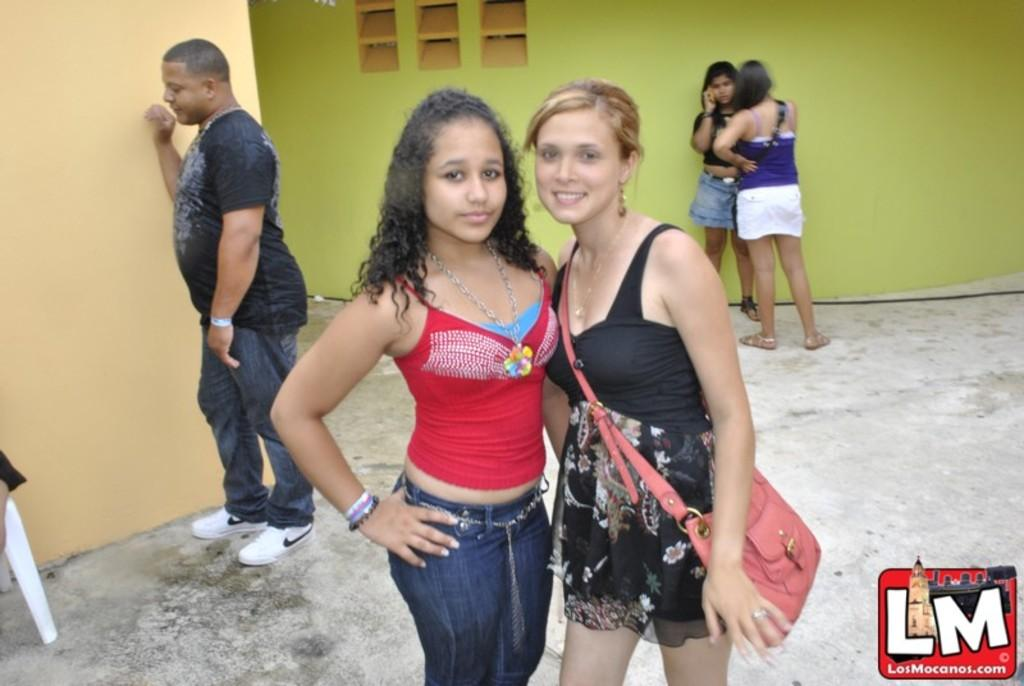How many women are present in the image? There are two women standing in the image. What is the position of the person in the image? There is a person sitting on a chair in the image. Can you describe the position of the other people in the image? There are people standing beside the walls in the image. What type of twig is being used by the women in the image? There is no twig present in the image. What adjustment is being made by the person sitting on the chair in the image? There is no adjustment being made by the person sitting on the chair in the image. 